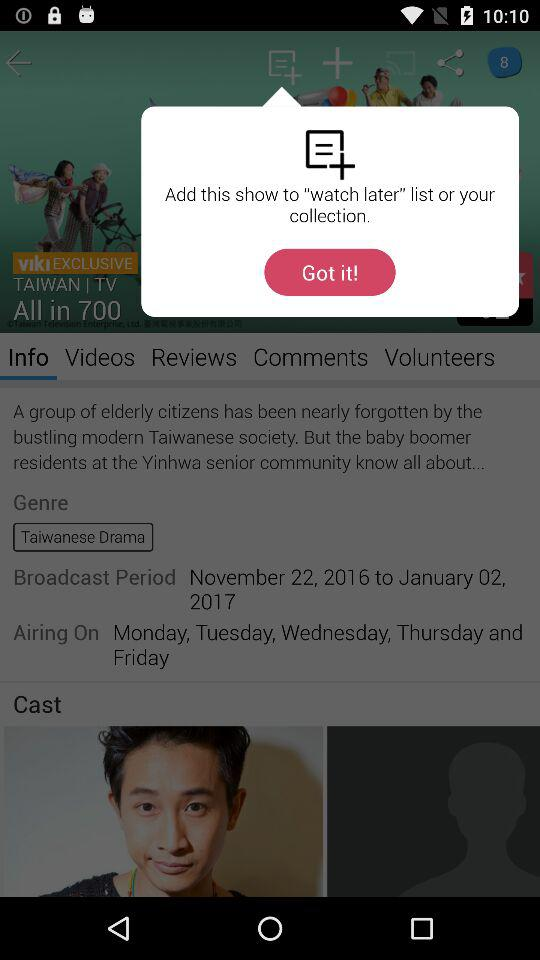How many volunteers are there?
When the provided information is insufficient, respond with <no answer>. <no answer> 